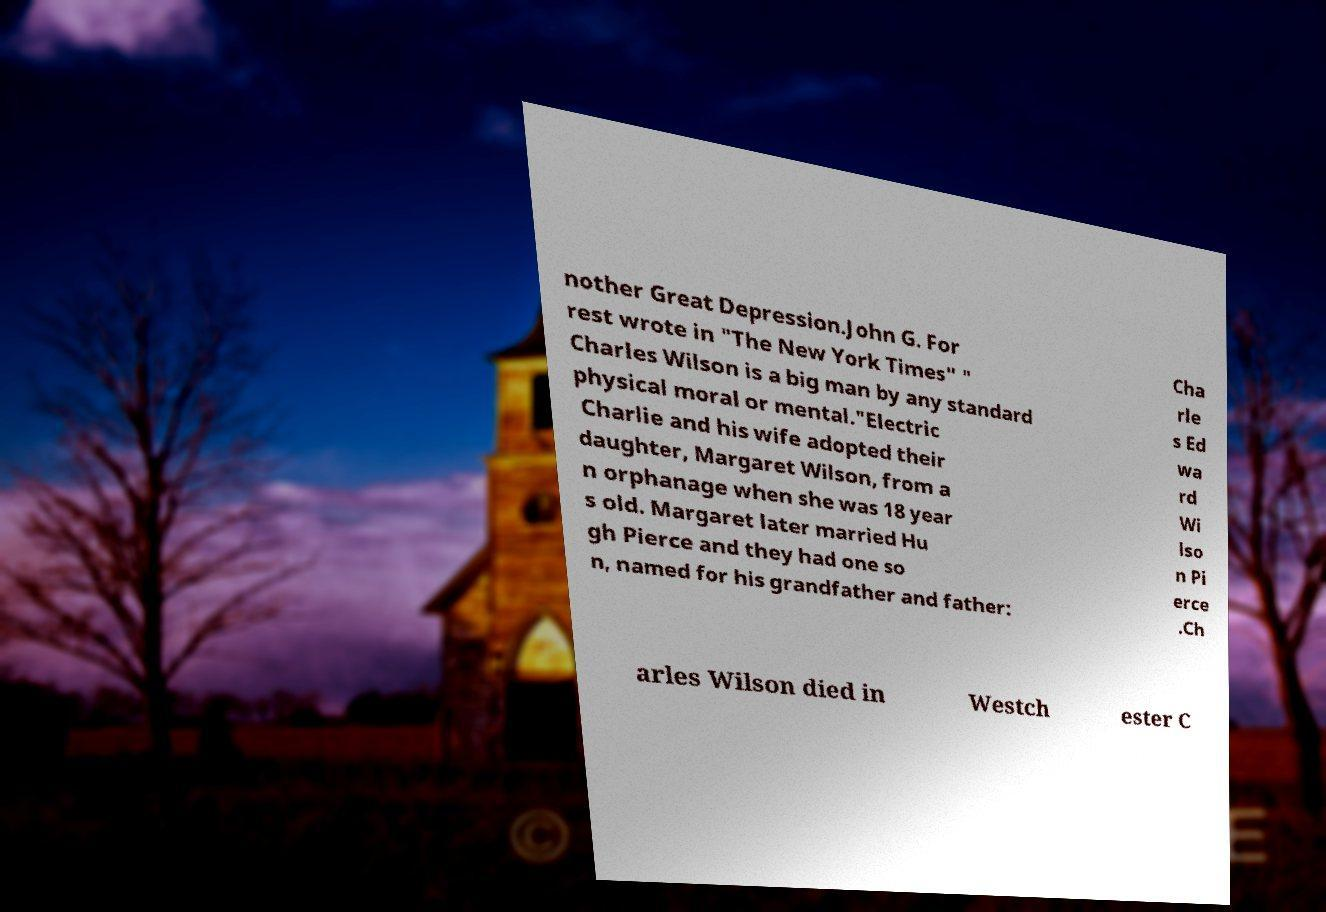Could you extract and type out the text from this image? nother Great Depression.John G. For rest wrote in "The New York Times" " Charles Wilson is a big man by any standard physical moral or mental."Electric Charlie and his wife adopted their daughter, Margaret Wilson, from a n orphanage when she was 18 year s old. Margaret later married Hu gh Pierce and they had one so n, named for his grandfather and father: Cha rle s Ed wa rd Wi lso n Pi erce .Ch arles Wilson died in Westch ester C 